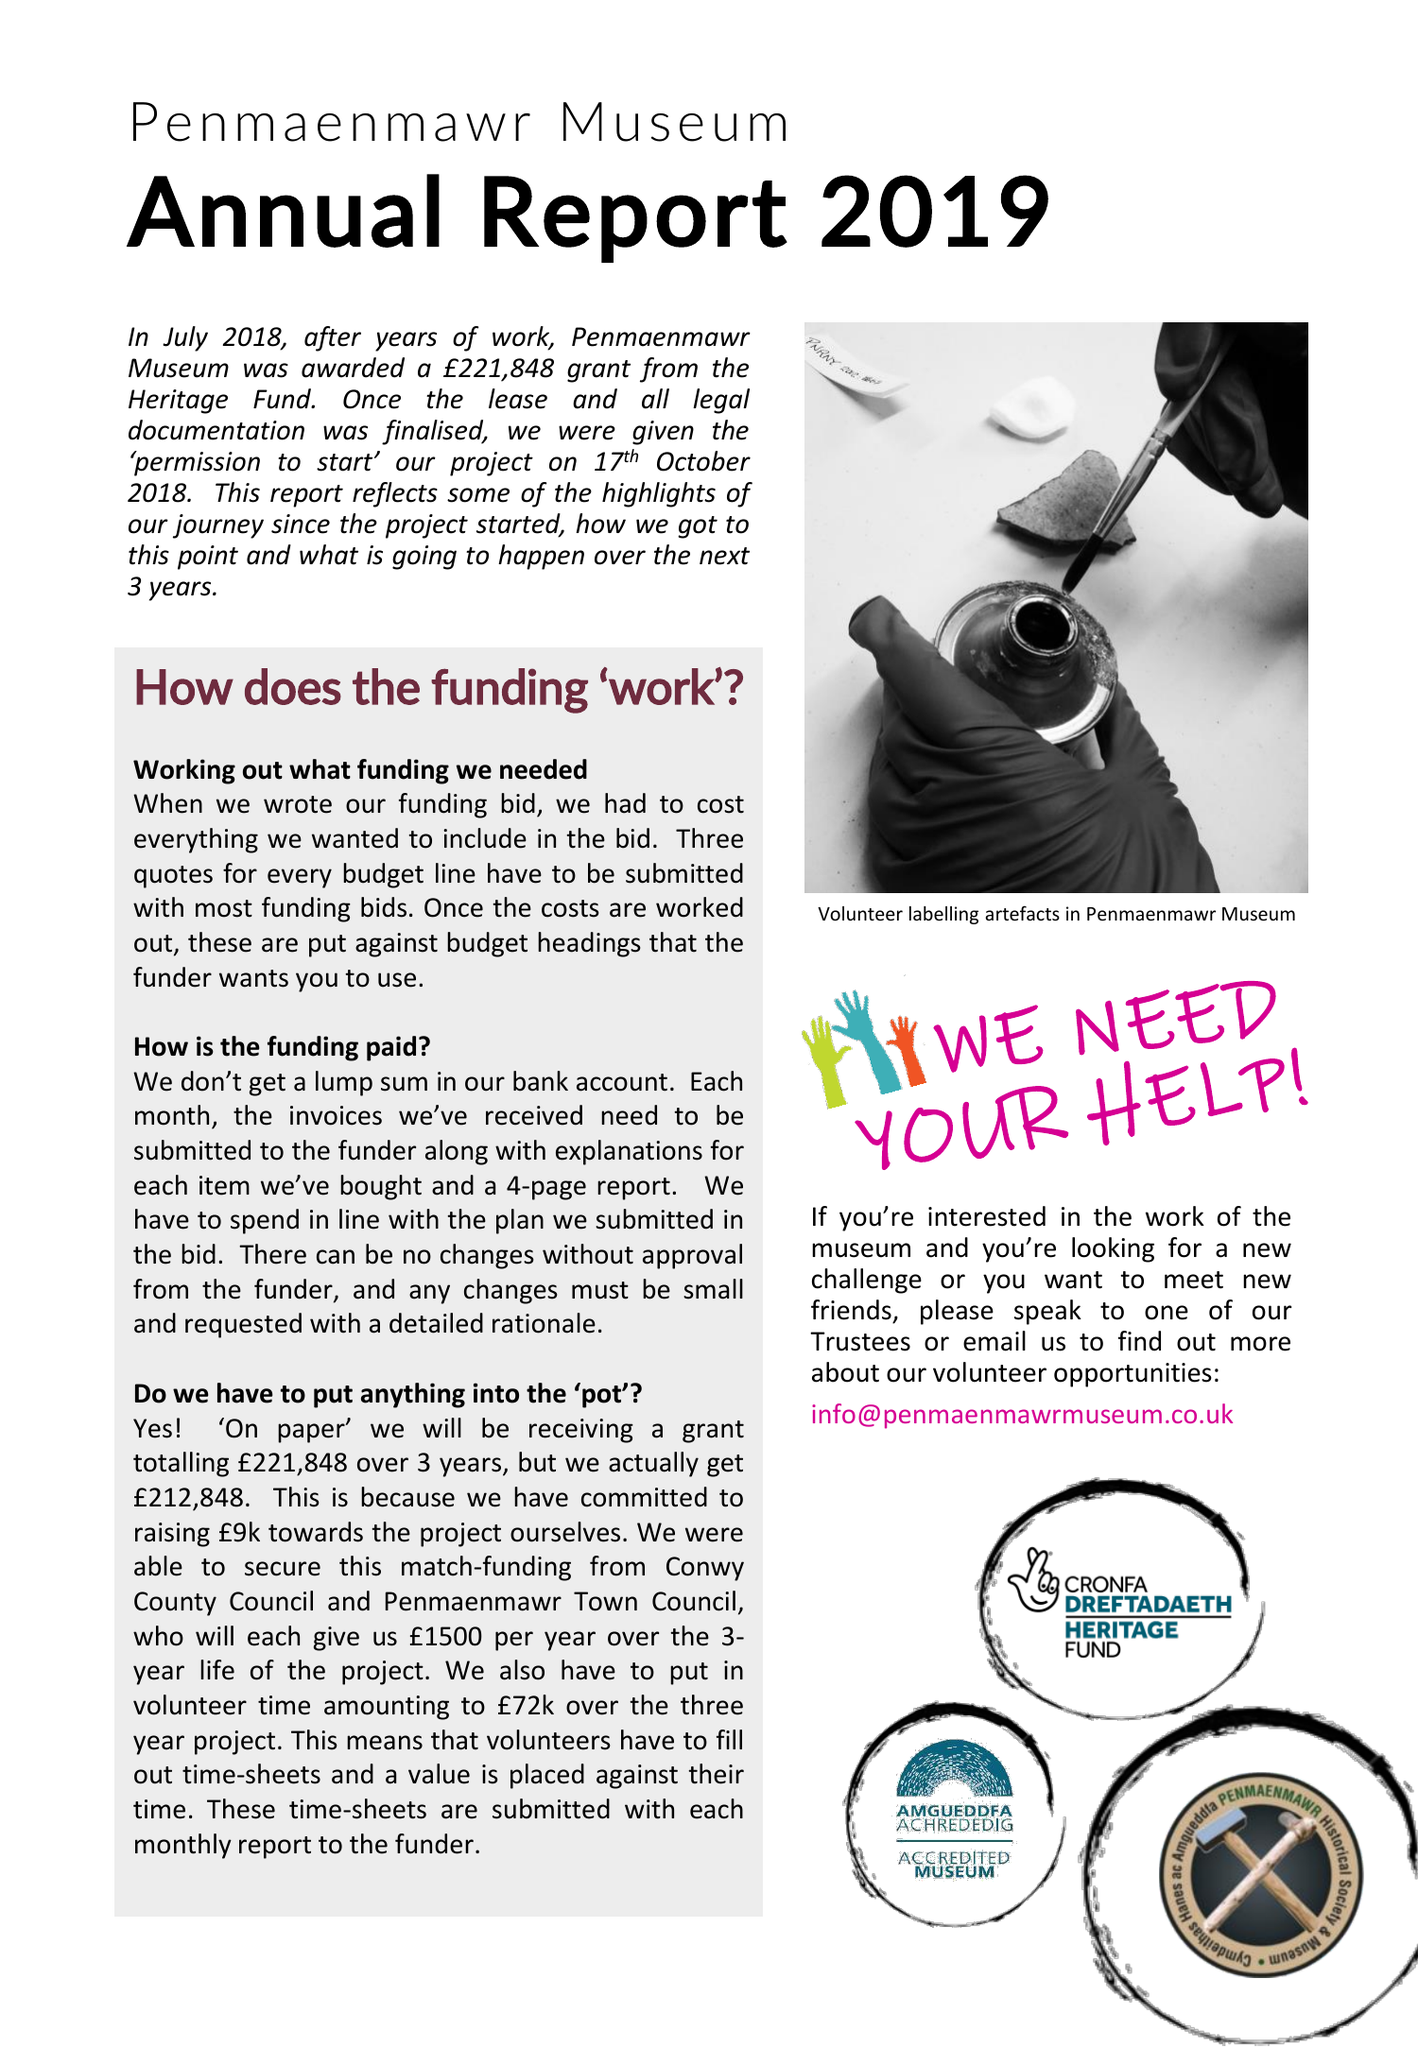What is the value for the charity_number?
Answer the question using a single word or phrase. 1148984 